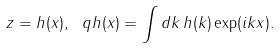<formula> <loc_0><loc_0><loc_500><loc_500>z = h ( x ) , \ q h ( x ) = \int d k \, h ( k ) \exp ( i k x ) .</formula> 